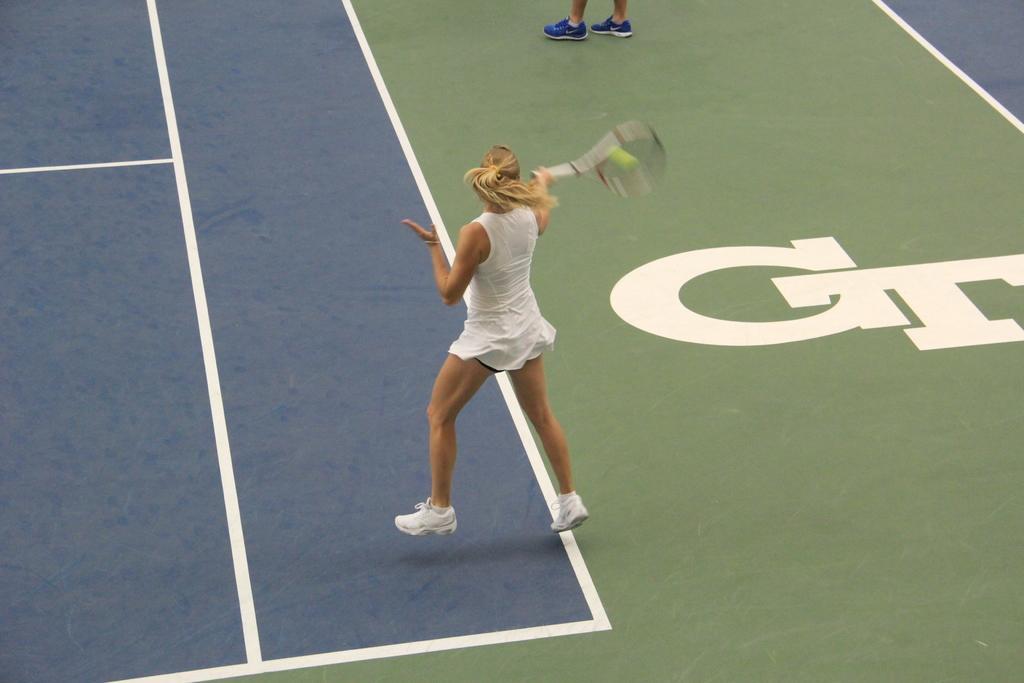Could you give a brief overview of what you see in this image? In this image, there is a person wearing clothes and playing tennis. This person is holding a tennis racket with her hand. 